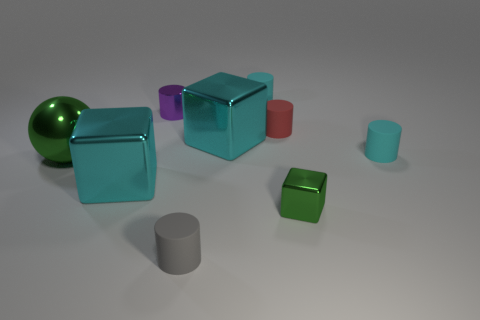Subtract all red cylinders. How many cylinders are left? 4 Subtract all gray cylinders. How many cylinders are left? 4 Subtract all purple cylinders. Subtract all cyan balls. How many cylinders are left? 4 Add 1 big metallic things. How many objects exist? 10 Subtract all cubes. How many objects are left? 6 Add 1 tiny gray cylinders. How many tiny gray cylinders are left? 2 Add 4 red rubber cylinders. How many red rubber cylinders exist? 5 Subtract 1 green blocks. How many objects are left? 8 Subtract all small cyan rubber balls. Subtract all metal blocks. How many objects are left? 6 